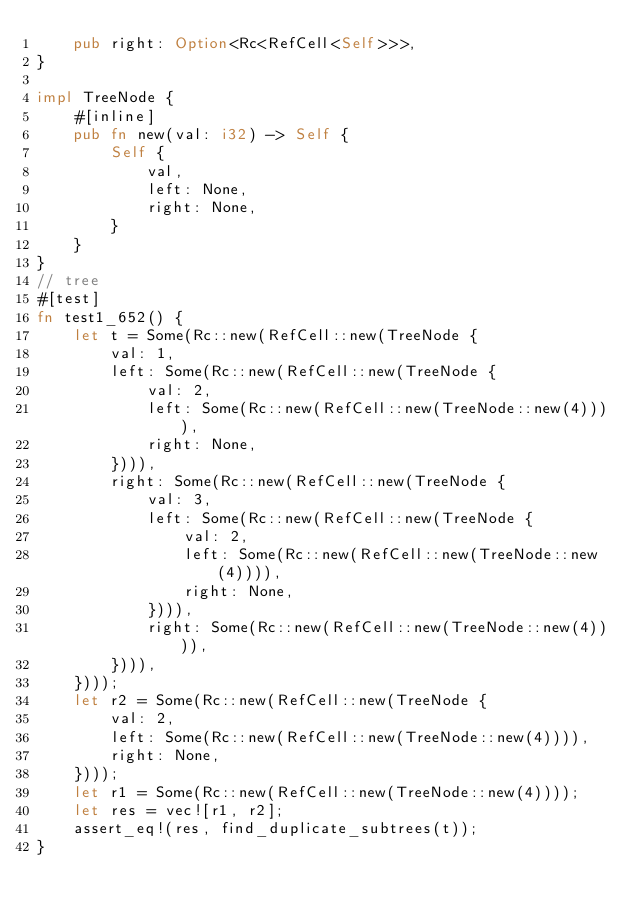Convert code to text. <code><loc_0><loc_0><loc_500><loc_500><_Rust_>    pub right: Option<Rc<RefCell<Self>>>,
}

impl TreeNode {
    #[inline]
    pub fn new(val: i32) -> Self {
        Self {
            val,
            left: None,
            right: None,
        }
    }
}
// tree
#[test]
fn test1_652() {
    let t = Some(Rc::new(RefCell::new(TreeNode {
        val: 1,
        left: Some(Rc::new(RefCell::new(TreeNode {
            val: 2,
            left: Some(Rc::new(RefCell::new(TreeNode::new(4)))),
            right: None,
        }))),
        right: Some(Rc::new(RefCell::new(TreeNode {
            val: 3,
            left: Some(Rc::new(RefCell::new(TreeNode {
                val: 2,
                left: Some(Rc::new(RefCell::new(TreeNode::new(4)))),
                right: None,
            }))),
            right: Some(Rc::new(RefCell::new(TreeNode::new(4)))),
        }))),
    })));
    let r2 = Some(Rc::new(RefCell::new(TreeNode {
        val: 2,
        left: Some(Rc::new(RefCell::new(TreeNode::new(4)))),
        right: None,
    })));
    let r1 = Some(Rc::new(RefCell::new(TreeNode::new(4))));
    let res = vec![r1, r2];
    assert_eq!(res, find_duplicate_subtrees(t));
}
</code> 